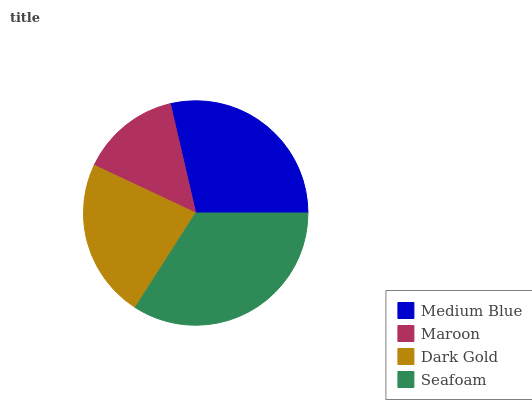Is Maroon the minimum?
Answer yes or no. Yes. Is Seafoam the maximum?
Answer yes or no. Yes. Is Dark Gold the minimum?
Answer yes or no. No. Is Dark Gold the maximum?
Answer yes or no. No. Is Dark Gold greater than Maroon?
Answer yes or no. Yes. Is Maroon less than Dark Gold?
Answer yes or no. Yes. Is Maroon greater than Dark Gold?
Answer yes or no. No. Is Dark Gold less than Maroon?
Answer yes or no. No. Is Medium Blue the high median?
Answer yes or no. Yes. Is Dark Gold the low median?
Answer yes or no. Yes. Is Seafoam the high median?
Answer yes or no. No. Is Seafoam the low median?
Answer yes or no. No. 